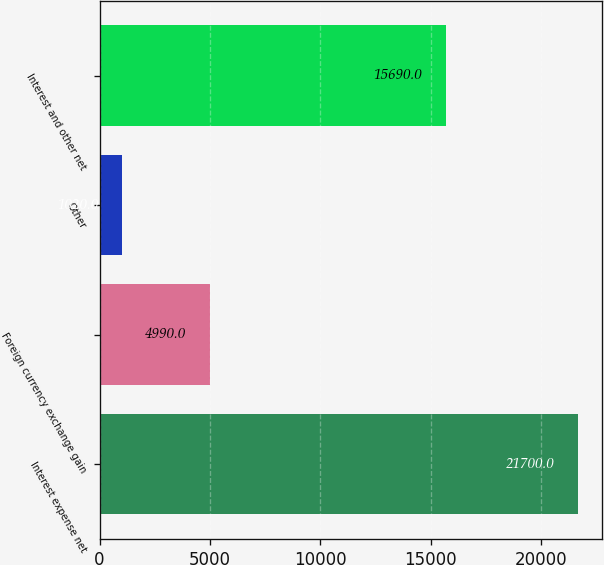Convert chart to OTSL. <chart><loc_0><loc_0><loc_500><loc_500><bar_chart><fcel>Interest expense net<fcel>Foreign currency exchange gain<fcel>Other<fcel>Interest and other net<nl><fcel>21700<fcel>4990<fcel>1020<fcel>15690<nl></chart> 